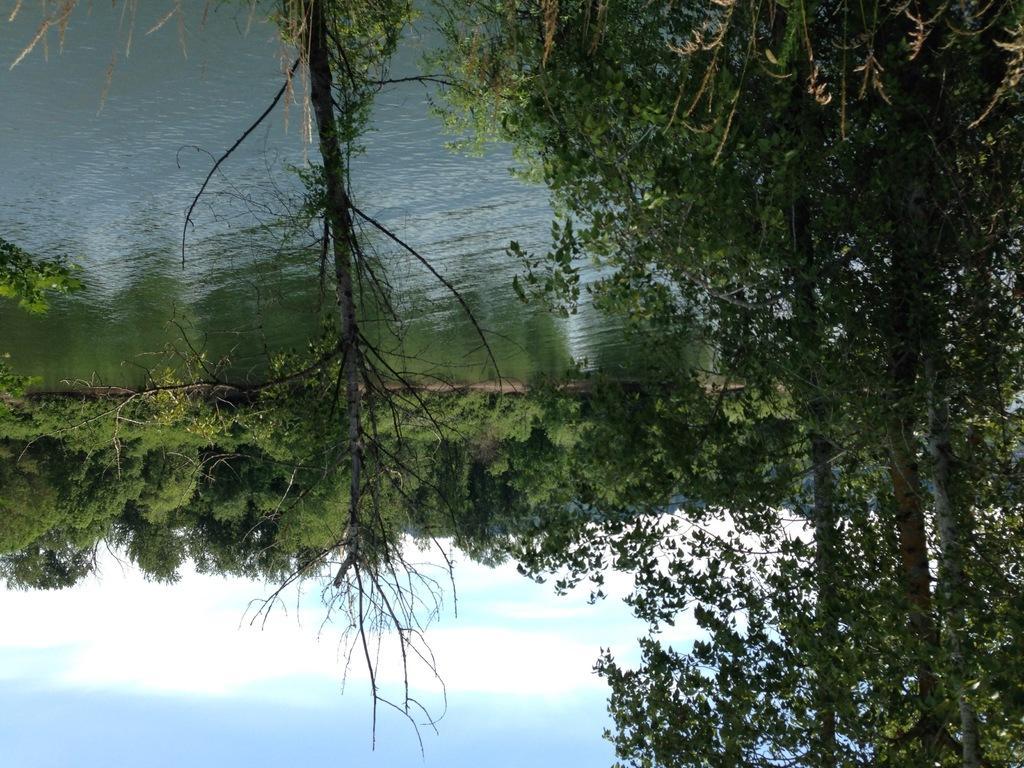Can you describe this image briefly? In this picture we can see few trees, water and clouds. 